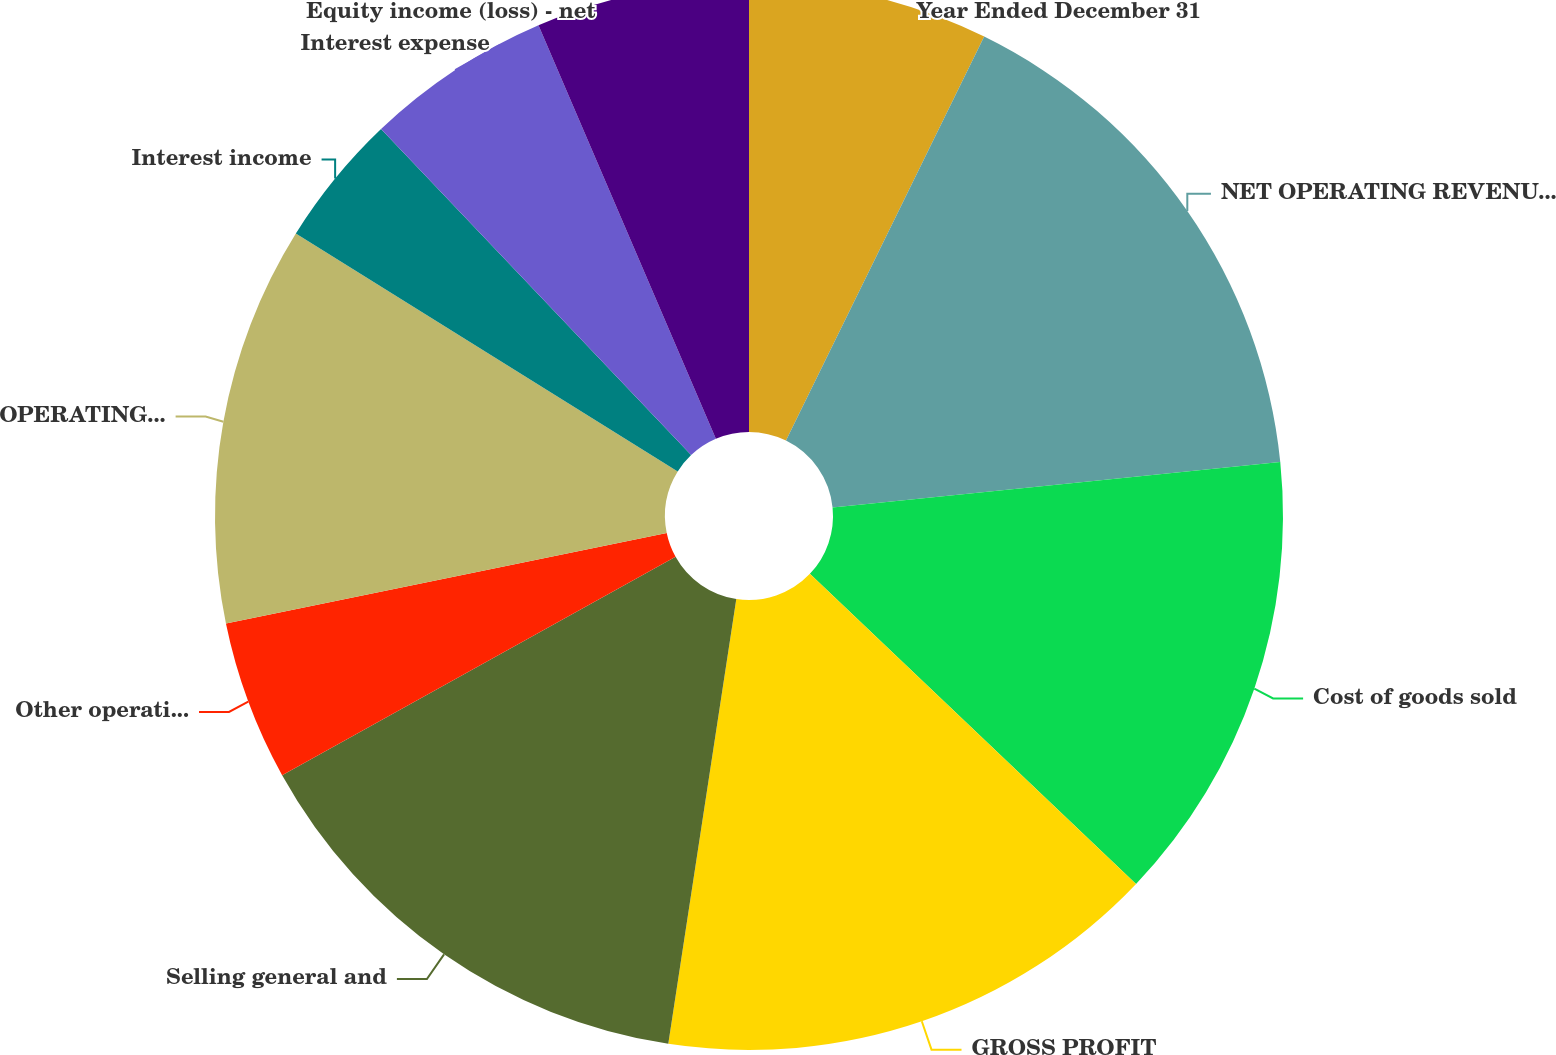Convert chart. <chart><loc_0><loc_0><loc_500><loc_500><pie_chart><fcel>Year Ended December 31<fcel>NET OPERATING REVENUES<fcel>Cost of goods sold<fcel>GROSS PROFIT<fcel>Selling general and<fcel>Other operating charges<fcel>OPERATING INCOME<fcel>Interest income<fcel>Interest expense<fcel>Equity income (loss) - net<nl><fcel>7.26%<fcel>16.13%<fcel>13.71%<fcel>15.32%<fcel>14.52%<fcel>4.84%<fcel>12.1%<fcel>4.03%<fcel>5.65%<fcel>6.45%<nl></chart> 